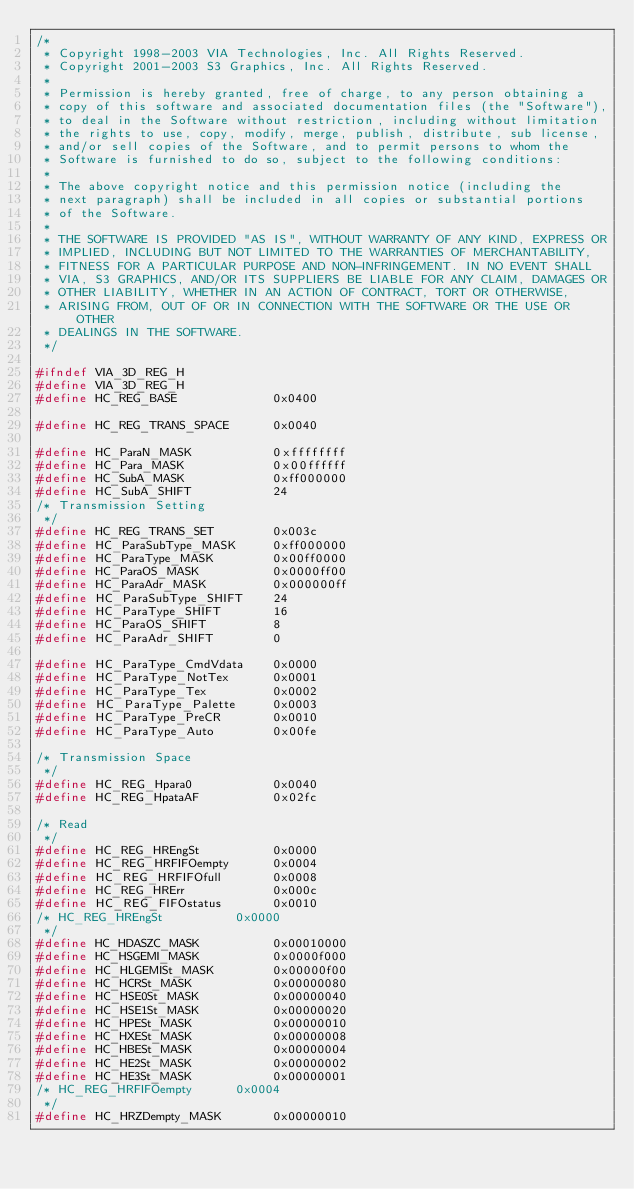<code> <loc_0><loc_0><loc_500><loc_500><_C_>/*
 * Copyright 1998-2003 VIA Technologies, Inc. All Rights Reserved.
 * Copyright 2001-2003 S3 Graphics, Inc. All Rights Reserved.
 *
 * Permission is hereby granted, free of charge, to any person obtaining a
 * copy of this software and associated documentation files (the "Software"),
 * to deal in the Software without restriction, including without limitation
 * the rights to use, copy, modify, merge, publish, distribute, sub license,
 * and/or sell copies of the Software, and to permit persons to whom the
 * Software is furnished to do so, subject to the following conditions:
 *
 * The above copyright notice and this permission notice (including the
 * next paragraph) shall be included in all copies or substantial portions
 * of the Software.
 *
 * THE SOFTWARE IS PROVIDED "AS IS", WITHOUT WARRANTY OF ANY KIND, EXPRESS OR
 * IMPLIED, INCLUDING BUT NOT LIMITED TO THE WARRANTIES OF MERCHANTABILITY,
 * FITNESS FOR A PARTICULAR PURPOSE AND NON-INFRINGEMENT. IN NO EVENT SHALL
 * VIA, S3 GRAPHICS, AND/OR ITS SUPPLIERS BE LIABLE FOR ANY CLAIM, DAMAGES OR
 * OTHER LIABILITY, WHETHER IN AN ACTION OF CONTRACT, TORT OR OTHERWISE,
 * ARISING FROM, OUT OF OR IN CONNECTION WITH THE SOFTWARE OR THE USE OR OTHER
 * DEALINGS IN THE SOFTWARE.
 */

#ifndef VIA_3D_REG_H
#define VIA_3D_REG_H
#define HC_REG_BASE             0x0400

#define HC_REG_TRANS_SPACE      0x0040

#define HC_ParaN_MASK           0xffffffff
#define HC_Para_MASK            0x00ffffff
#define HC_SubA_MASK            0xff000000
#define HC_SubA_SHIFT           24
/* Transmission Setting
 */
#define HC_REG_TRANS_SET        0x003c
#define HC_ParaSubType_MASK     0xff000000
#define HC_ParaType_MASK        0x00ff0000
#define HC_ParaOS_MASK          0x0000ff00
#define HC_ParaAdr_MASK         0x000000ff
#define HC_ParaSubType_SHIFT    24
#define HC_ParaType_SHIFT       16
#define HC_ParaOS_SHIFT         8
#define HC_ParaAdr_SHIFT        0

#define HC_ParaType_CmdVdata    0x0000
#define HC_ParaType_NotTex      0x0001
#define HC_ParaType_Tex         0x0002
#define HC_ParaType_Palette     0x0003
#define HC_ParaType_PreCR       0x0010
#define HC_ParaType_Auto        0x00fe

/* Transmission Space
 */
#define HC_REG_Hpara0           0x0040
#define HC_REG_HpataAF          0x02fc

/* Read
 */
#define HC_REG_HREngSt          0x0000
#define HC_REG_HRFIFOempty      0x0004
#define HC_REG_HRFIFOfull       0x0008
#define HC_REG_HRErr            0x000c
#define HC_REG_FIFOstatus       0x0010
/* HC_REG_HREngSt          0x0000
 */
#define HC_HDASZC_MASK          0x00010000
#define HC_HSGEMI_MASK          0x0000f000
#define HC_HLGEMISt_MASK        0x00000f00
#define HC_HCRSt_MASK           0x00000080
#define HC_HSE0St_MASK          0x00000040
#define HC_HSE1St_MASK          0x00000020
#define HC_HPESt_MASK           0x00000010
#define HC_HXESt_MASK           0x00000008
#define HC_HBESt_MASK           0x00000004
#define HC_HE2St_MASK           0x00000002
#define HC_HE3St_MASK           0x00000001
/* HC_REG_HRFIFOempty      0x0004
 */
#define HC_HRZDempty_MASK       0x00000010</code> 